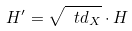<formula> <loc_0><loc_0><loc_500><loc_500>H ^ { \prime } = \sqrt { \ t d _ { X } } \cdot H</formula> 